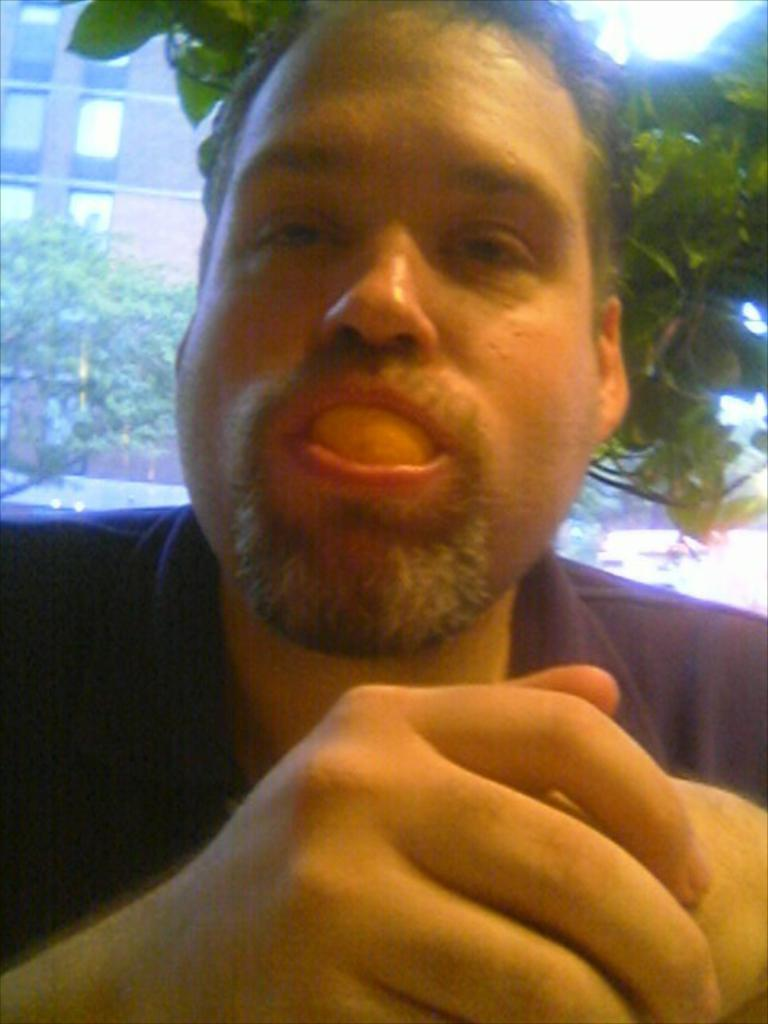What is the main subject in the center of the image? There is a person in the center of the image. What can be seen in the background of the image? There are trees, vehicles, buildings, and the sky visible in the background of the image. What flavor of ghost can be seen in the image? There are no ghosts present in the image, so it is not possible to determine the flavor of any ghost. 